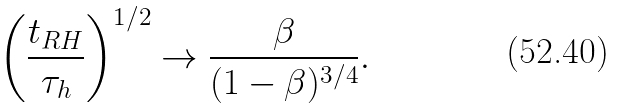<formula> <loc_0><loc_0><loc_500><loc_500>\left ( \frac { t _ { R H } } { \tau _ { h } } \right ) ^ { 1 / 2 } \to \frac { \beta } { ( 1 - \beta ) ^ { 3 / 4 } } .</formula> 